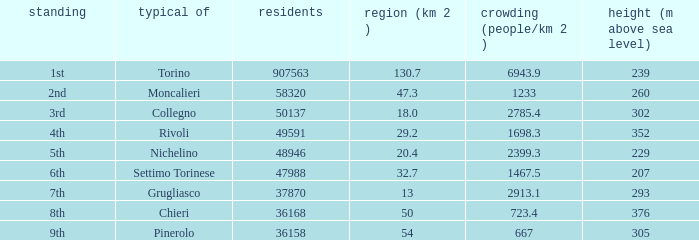7 km^2 possess? 1.0. 